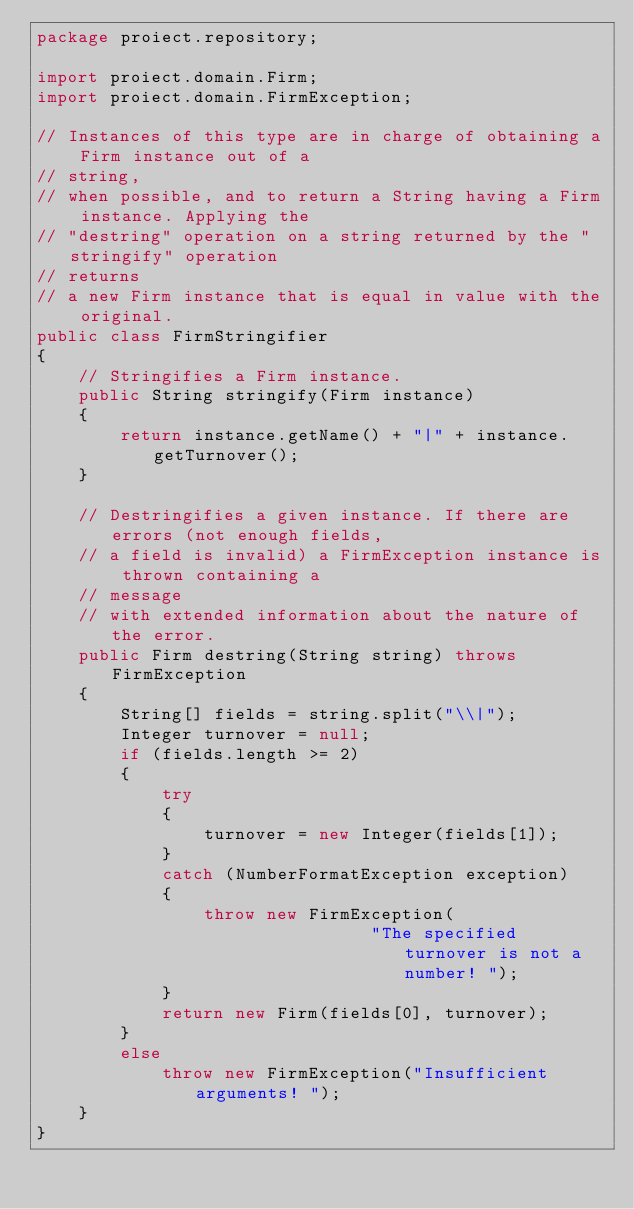Convert code to text. <code><loc_0><loc_0><loc_500><loc_500><_Java_>package proiect.repository;

import proiect.domain.Firm;
import proiect.domain.FirmException;

// Instances of this type are in charge of obtaining a Firm instance out of a
// string,
// when possible, and to return a String having a Firm instance. Applying the
// "destring" operation on a string returned by the "stringify" operation
// returns
// a new Firm instance that is equal in value with the original.
public class FirmStringifier
{
    // Stringifies a Firm instance.
    public String stringify(Firm instance)
    {
        return instance.getName() + "|" + instance.getTurnover();
    }

    // Destringifies a given instance. If there are errors (not enough fields,
    // a field is invalid) a FirmException instance is thrown containing a
    // message
    // with extended information about the nature of the error.
    public Firm destring(String string) throws FirmException
    {
        String[] fields = string.split("\\|");
        Integer turnover = null;
        if (fields.length >= 2)
        {
            try
            {
                turnover = new Integer(fields[1]);
            }
            catch (NumberFormatException exception)
            {
                throw new FirmException(
                                "The specified turnover is not a number! ");
            }
            return new Firm(fields[0], turnover);
        }
        else
            throw new FirmException("Insufficient arguments! ");
    }
}
</code> 